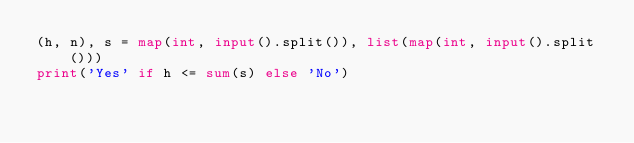<code> <loc_0><loc_0><loc_500><loc_500><_Python_>(h, n), s = map(int, input().split()), list(map(int, input().split()))
print('Yes' if h <= sum(s) else 'No')</code> 